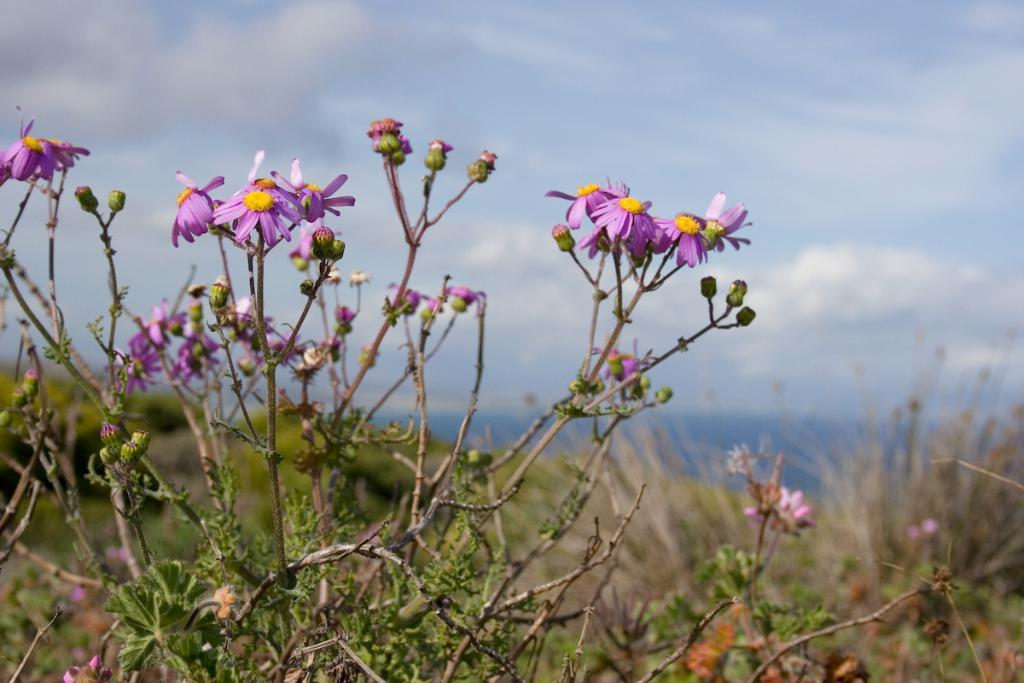What type of living organisms can be seen in the image? There are flowers in the image. Where are the flowers located? The flowers are on plants. What color are the flowers? The flowers are in violet color. What can be seen in the background of the image? Water is visible in the background of the image. How would you describe the weather in the image? The sky is cloudy in the image, suggesting a potentially overcast or rainy day. What type of note is attached to the wall in the image? There is no wall or note present in the image; it features flowers on plants with a cloudy sky in the background. 